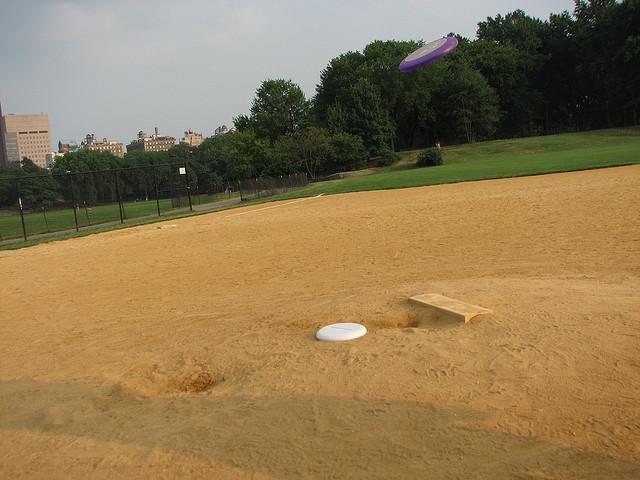What sport are they playing?
Answer briefly. Frisbee. What color is the frisbee in the air?
Answer briefly. Purple. What color is the field?
Keep it brief. Brown. Is there grass?
Answer briefly. Yes. How many plants are in the ring around the bench?
Keep it brief. 0. How many Frisbees are visible?
Give a very brief answer. 1. Can night games be played in this field?
Quick response, please. No. 